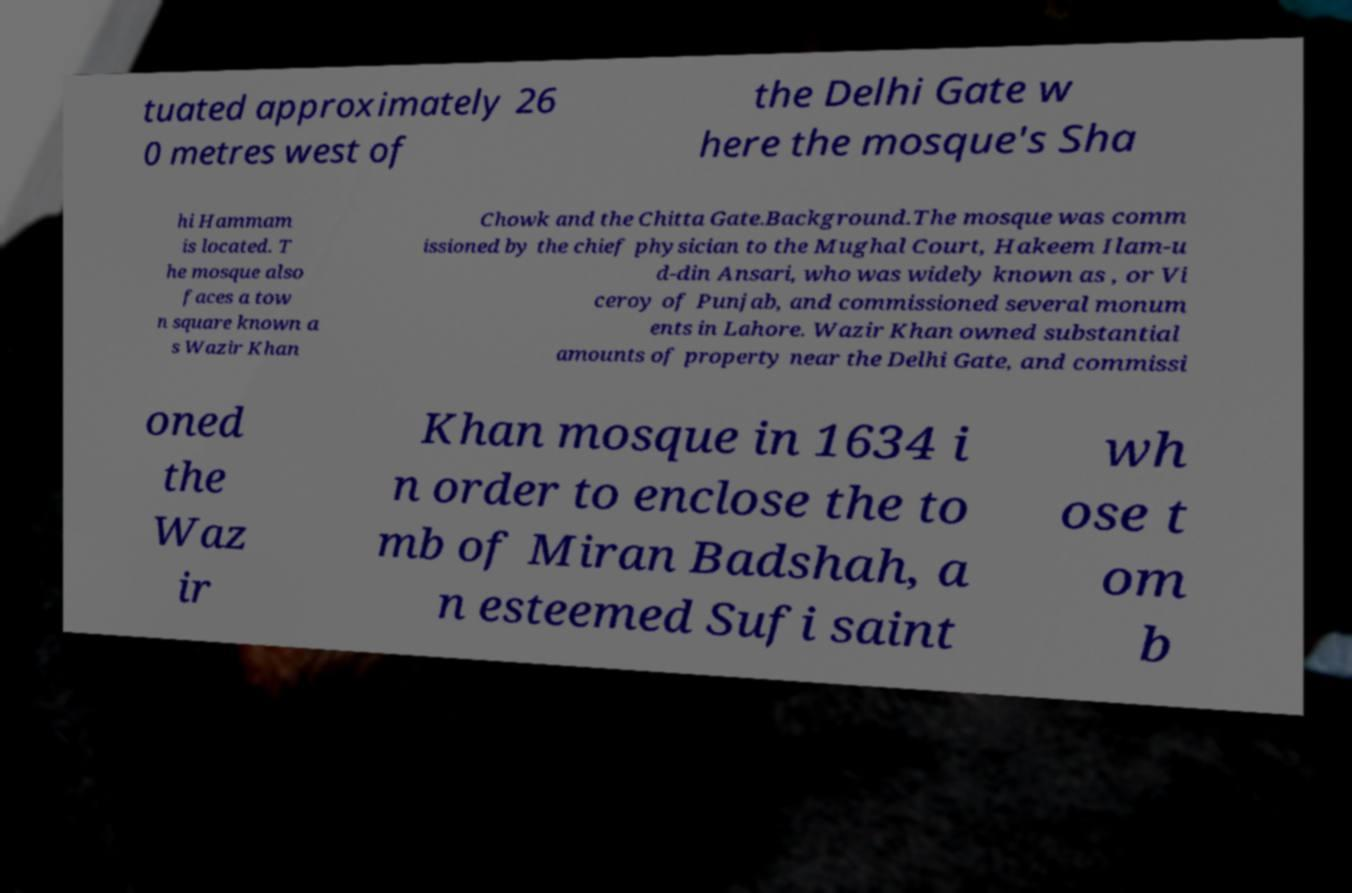Could you assist in decoding the text presented in this image and type it out clearly? tuated approximately 26 0 metres west of the Delhi Gate w here the mosque's Sha hi Hammam is located. T he mosque also faces a tow n square known a s Wazir Khan Chowk and the Chitta Gate.Background.The mosque was comm issioned by the chief physician to the Mughal Court, Hakeem Ilam-u d-din Ansari, who was widely known as , or Vi ceroy of Punjab, and commissioned several monum ents in Lahore. Wazir Khan owned substantial amounts of property near the Delhi Gate, and commissi oned the Waz ir Khan mosque in 1634 i n order to enclose the to mb of Miran Badshah, a n esteemed Sufi saint wh ose t om b 